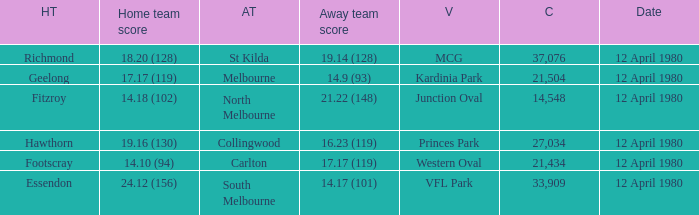Where did fitzroy play as the home team? Junction Oval. 